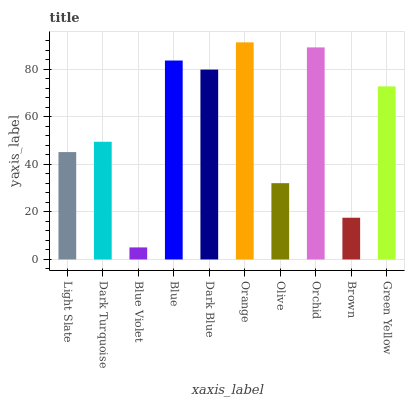Is Blue Violet the minimum?
Answer yes or no. Yes. Is Orange the maximum?
Answer yes or no. Yes. Is Dark Turquoise the minimum?
Answer yes or no. No. Is Dark Turquoise the maximum?
Answer yes or no. No. Is Dark Turquoise greater than Light Slate?
Answer yes or no. Yes. Is Light Slate less than Dark Turquoise?
Answer yes or no. Yes. Is Light Slate greater than Dark Turquoise?
Answer yes or no. No. Is Dark Turquoise less than Light Slate?
Answer yes or no. No. Is Green Yellow the high median?
Answer yes or no. Yes. Is Dark Turquoise the low median?
Answer yes or no. Yes. Is Light Slate the high median?
Answer yes or no. No. Is Brown the low median?
Answer yes or no. No. 